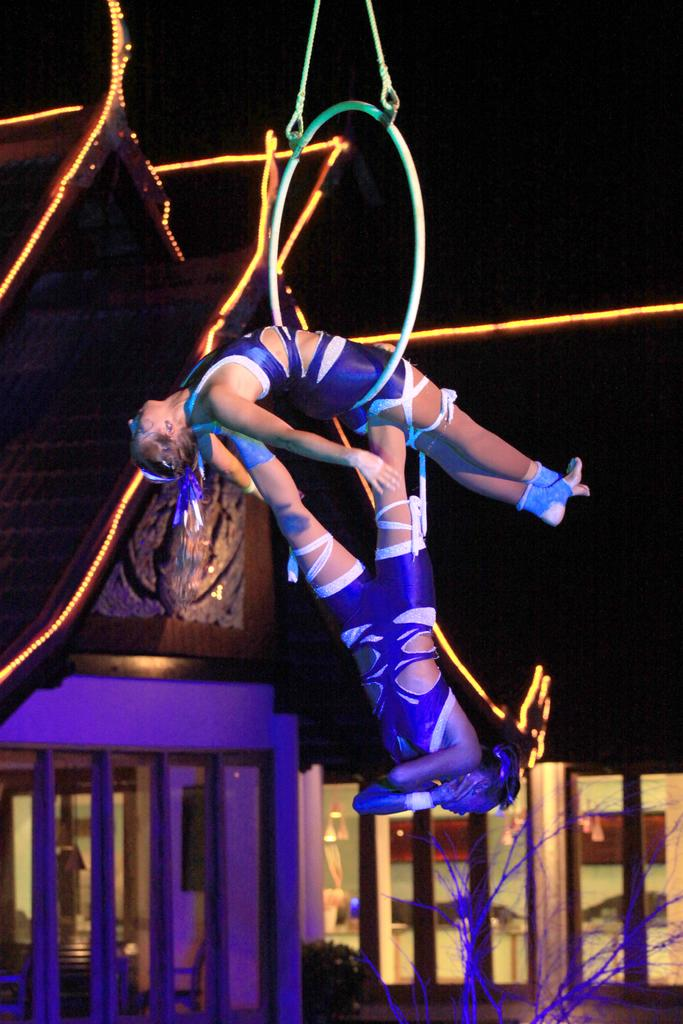How many people are in the image? There are people in the image, but the exact number cannot be determined from the provided facts. What object can be seen in the image that might be used for a ceremony or symbolize a commitment? There is a ring in the image. What type of material is used for the ropes in the image? The material of the ropes cannot be determined from the provided facts. What type of lighting is present in the image? Decorative lights are present in the image. What type of architectural feature is visible in the image? There are glass windows in the image. What type of natural element is visible in the image? There are branches in the image. What type of vegetation is visible in the distance? There is a plant visible in the distance. What type of cannon is visible in the image? There is no cannon present in the image. What type of harbor can be seen in the image? There is no harbor present in the image. 